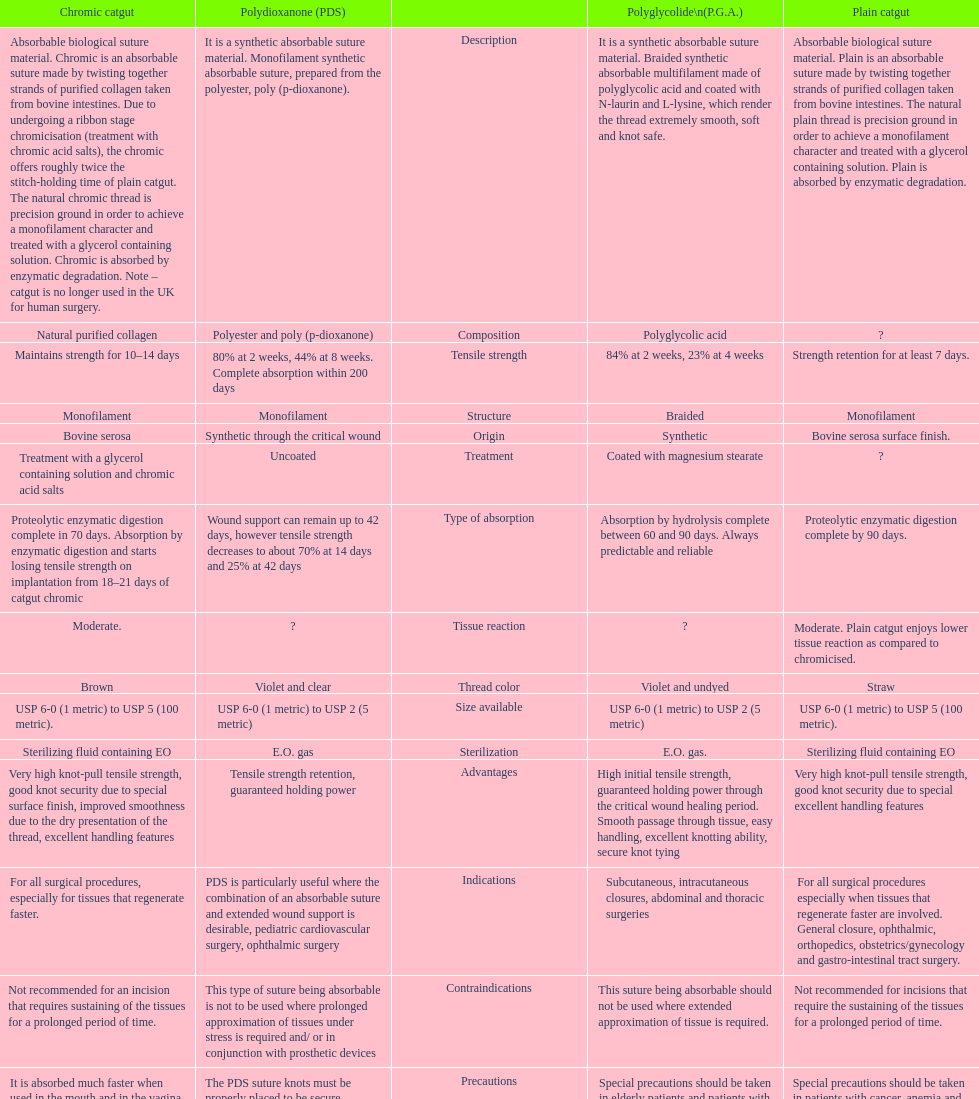Which suture can remain to at most 42 days Polydioxanone (PDS). 